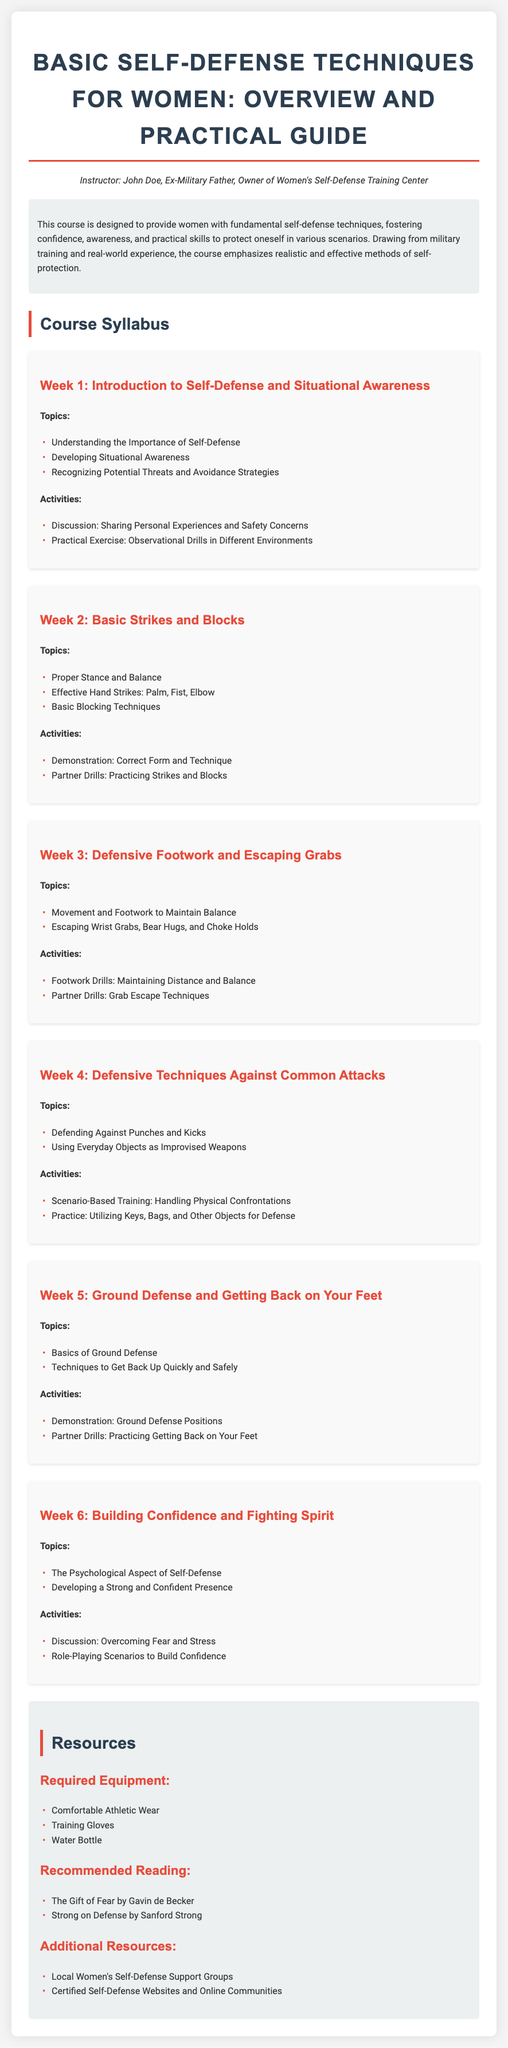what is the title of the syllabus? The title of the syllabus is the main heading of the document, which states the focus of the course.
Answer: Basic Self-Defense Techniques for Women: Overview and Practical Guide who is the instructor of the course? The instructor's name is mentioned in the introductory section of the document.
Answer: John Doe how many weeks is the course structured into? The syllabus lists the course duration in weeks within the course content section.
Answer: 6 what is one topic covered in Week 2? The topics for each week are outlined in the respective sections, specifically for Week 2.
Answer: Effective Hand Strikes: Palm, Fist, Elbow what type of drills are mentioned in Week 3? The activities section lists the drills planned for that week and describes them.
Answer: Footwork Drills what psychological aspect is discussed in Week 6? This refers to the topics of discussions slated for the final week, focusing on mindset.
Answer: The Psychological Aspect of Self-Defense what is required equipment for the course? The required items for participants are listed under the resources section.
Answer: Comfortable Athletic Wear which book is recommended reading for this course? This detail is found in the resources section where recommended materials are provided.
Answer: The Gift of Fear by Gavin de Becker 